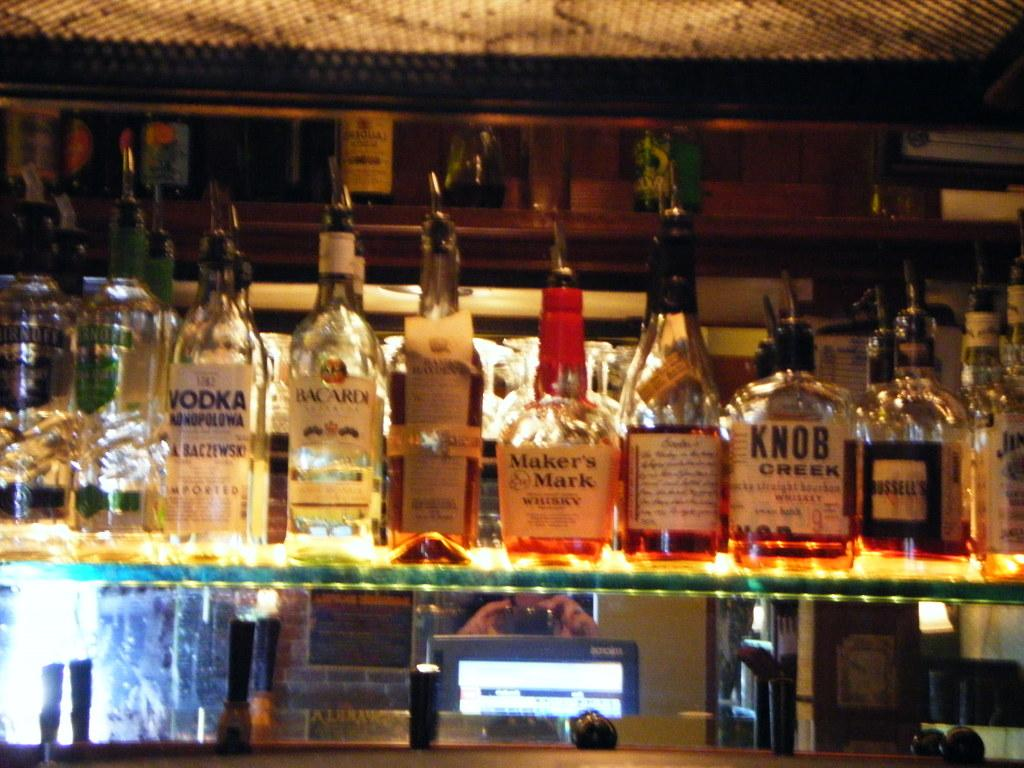What objects are on the shelf in the image? There are bottles on a shelf in the image. Can you describe the person in the image? There is a person sitting far away in the image. What type of food is being prepared on the canvas in the image? There is no canvas or food preparation visible in the image; it only features bottles on a shelf and a person sitting far away. 